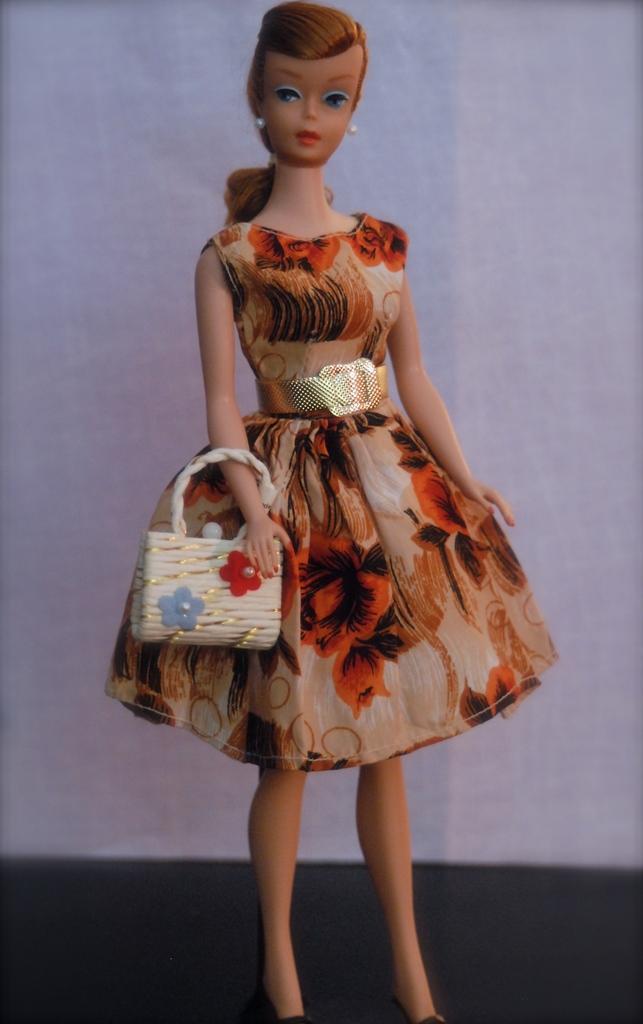What is the main subject of the image? There is a doll in the image. What is the doll wearing? The doll is wearing a floral dress. What is the doll holding in her hand? The doll is holding a white bag with her right hand. What type of ant can be seen crawling on the doll's floral dress in the image? There are no ants present in the image, and therefore no such activity can be observed. 